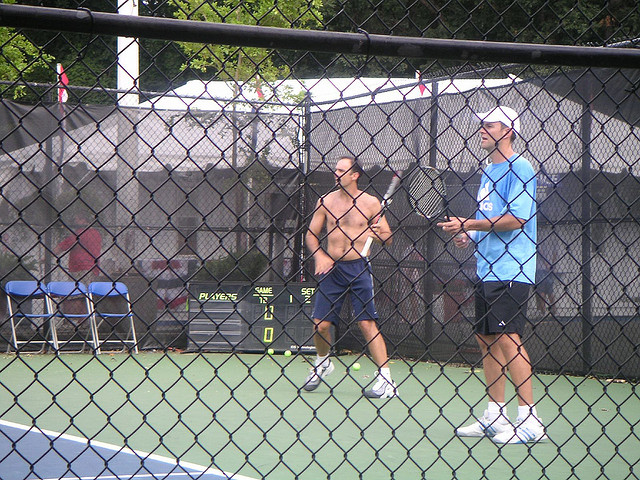Describe the environment surrounding the players. The players are surrounded by a chain-link fence that encloses the court. Beyond the fence, there is dense foliage, suggesting the court is likely in a park or similar green space. There are also some objects, perhaps personal belongings, placed on a chair outside the court. Is there anything unique or noteworthy about the players' attire? One player is shirtless, which is unusual for many sports but might suggest a casual game or a particularly hot day. Both players are in athletic shorts and sneakers, which is typical attire for an athletic activity like this one. 